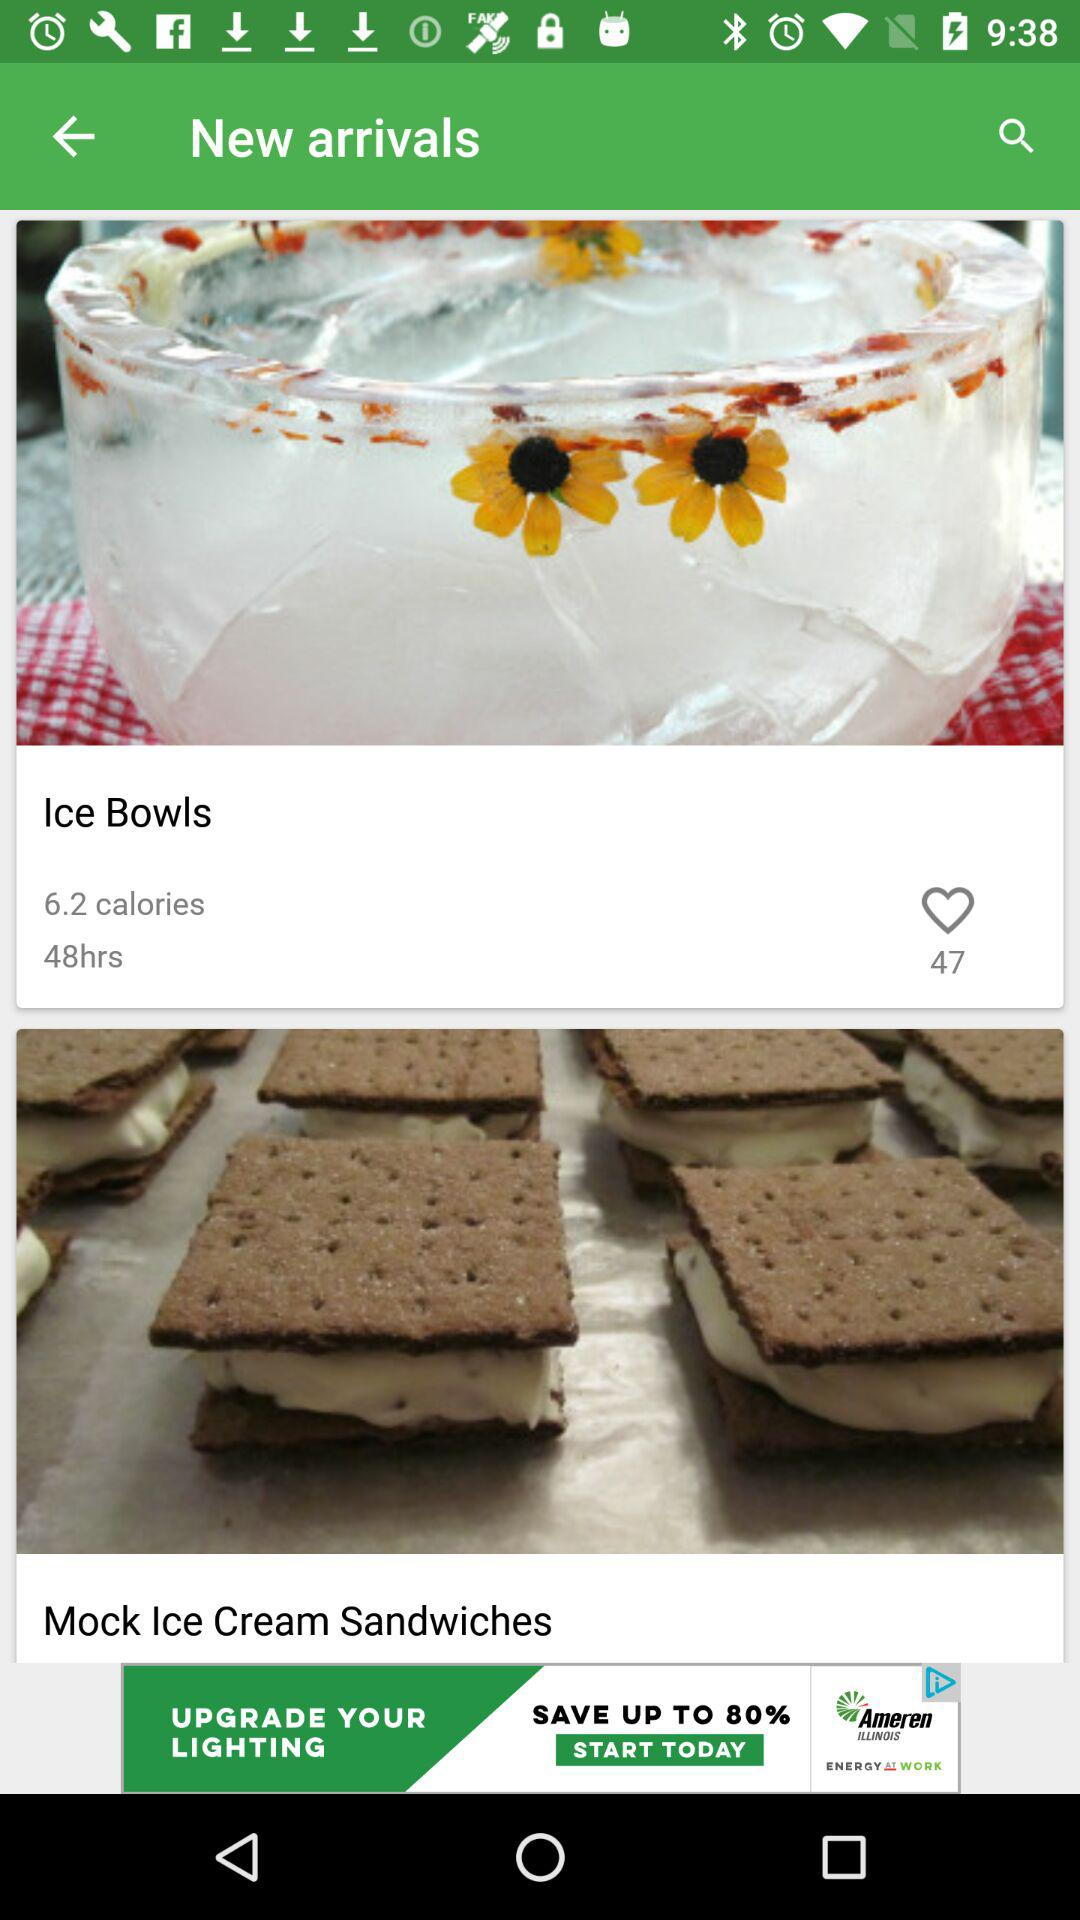What is the number of likes of "Ice Bowls"? The number of likes of "Ice Bowls" is 47. 